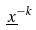Convert formula to latex. <formula><loc_0><loc_0><loc_500><loc_500>\underline { x } ^ { - k }</formula> 